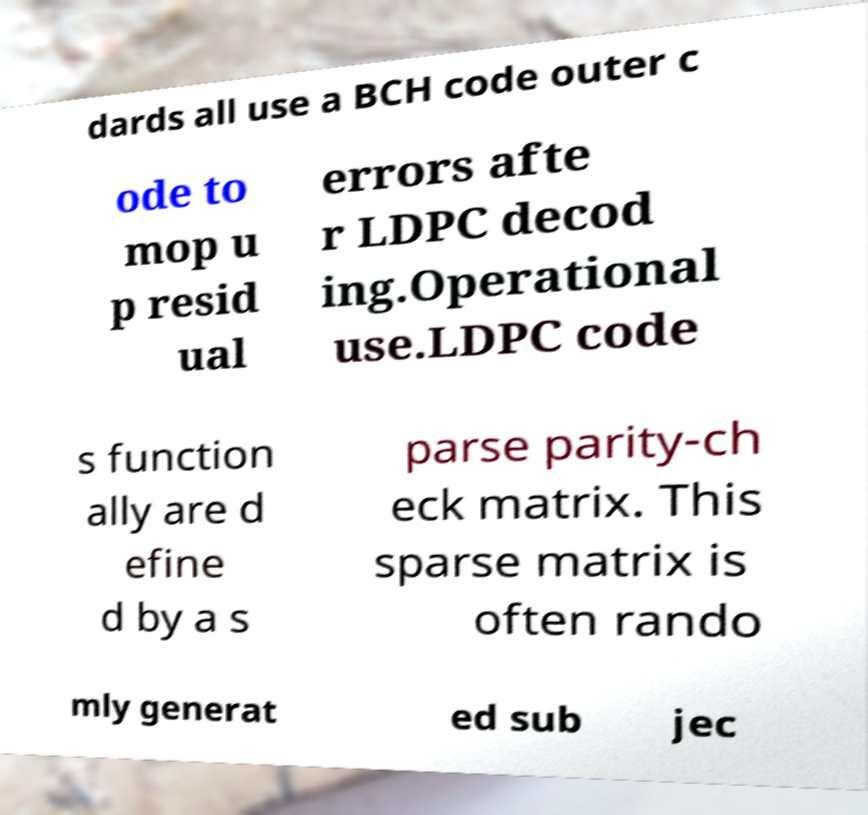Could you extract and type out the text from this image? dards all use a BCH code outer c ode to mop u p resid ual errors afte r LDPC decod ing.Operational use.LDPC code s function ally are d efine d by a s parse parity-ch eck matrix. This sparse matrix is often rando mly generat ed sub jec 